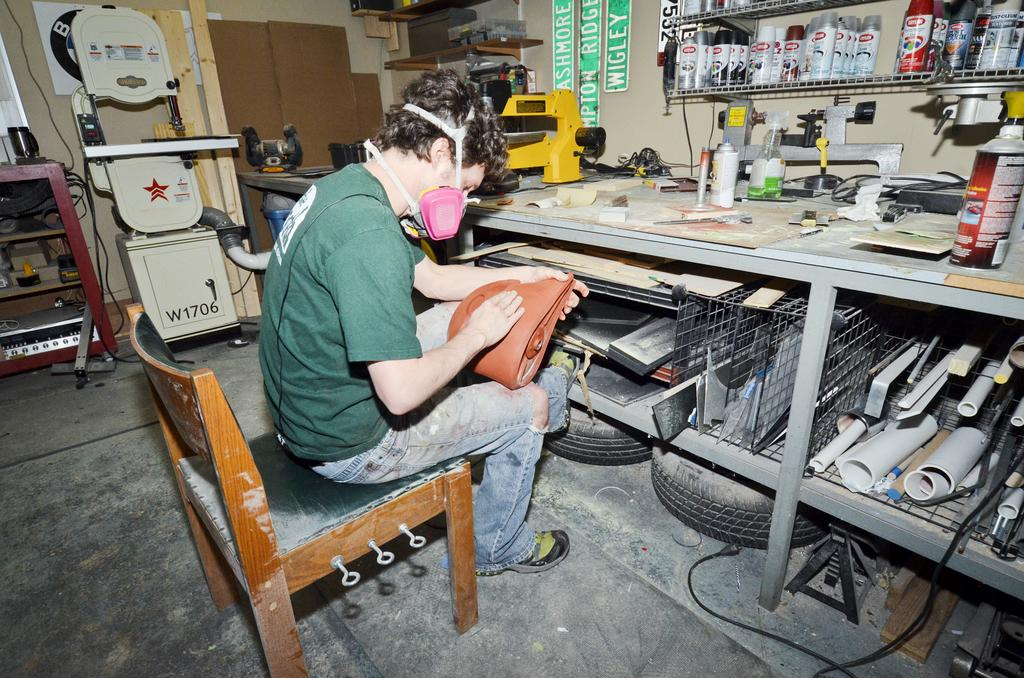What is the position of the man in the image? The man is sitting in the image. What is the man wearing on his face? The man is wearing a mask in the image. What is the man holding in his hand? The man is holding an object in the image. What is in front of the man? There is a table in front of the man in the image. What can be seen on the floor near the man? There is a tire on the floor in the image. What type of pets does the scarecrow have in the image? There is no scarecrow or pets present in the image. 